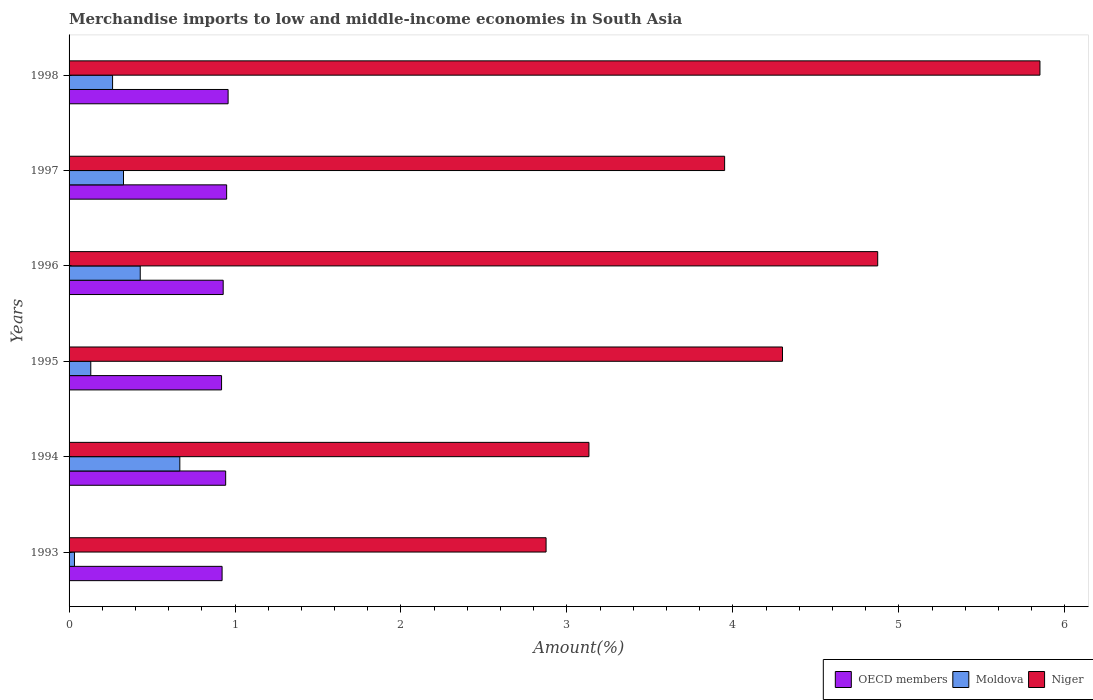How many different coloured bars are there?
Make the answer very short. 3. How many groups of bars are there?
Offer a very short reply. 6. Are the number of bars per tick equal to the number of legend labels?
Provide a succinct answer. Yes. How many bars are there on the 6th tick from the top?
Offer a terse response. 3. What is the label of the 1st group of bars from the top?
Make the answer very short. 1998. In how many cases, is the number of bars for a given year not equal to the number of legend labels?
Your answer should be very brief. 0. What is the percentage of amount earned from merchandise imports in OECD members in 1997?
Give a very brief answer. 0.95. Across all years, what is the maximum percentage of amount earned from merchandise imports in Moldova?
Provide a short and direct response. 0.67. Across all years, what is the minimum percentage of amount earned from merchandise imports in Niger?
Your answer should be very brief. 2.87. In which year was the percentage of amount earned from merchandise imports in Moldova minimum?
Provide a short and direct response. 1993. What is the total percentage of amount earned from merchandise imports in Niger in the graph?
Keep it short and to the point. 24.98. What is the difference between the percentage of amount earned from merchandise imports in Niger in 1994 and that in 1997?
Offer a terse response. -0.82. What is the difference between the percentage of amount earned from merchandise imports in Moldova in 1993 and the percentage of amount earned from merchandise imports in Niger in 1995?
Make the answer very short. -4.27. What is the average percentage of amount earned from merchandise imports in Niger per year?
Provide a short and direct response. 4.16. In the year 1996, what is the difference between the percentage of amount earned from merchandise imports in OECD members and percentage of amount earned from merchandise imports in Moldova?
Offer a terse response. 0.5. In how many years, is the percentage of amount earned from merchandise imports in Niger greater than 3 %?
Provide a short and direct response. 5. What is the ratio of the percentage of amount earned from merchandise imports in OECD members in 1993 to that in 1994?
Keep it short and to the point. 0.98. Is the percentage of amount earned from merchandise imports in Moldova in 1994 less than that in 1997?
Ensure brevity in your answer.  No. What is the difference between the highest and the second highest percentage of amount earned from merchandise imports in OECD members?
Your answer should be compact. 0.01. What is the difference between the highest and the lowest percentage of amount earned from merchandise imports in Niger?
Provide a succinct answer. 2.98. Is the sum of the percentage of amount earned from merchandise imports in Niger in 1994 and 1997 greater than the maximum percentage of amount earned from merchandise imports in OECD members across all years?
Provide a succinct answer. Yes. What does the 1st bar from the top in 1993 represents?
Provide a succinct answer. Niger. What does the 2nd bar from the bottom in 1995 represents?
Your response must be concise. Moldova. Is it the case that in every year, the sum of the percentage of amount earned from merchandise imports in Niger and percentage of amount earned from merchandise imports in Moldova is greater than the percentage of amount earned from merchandise imports in OECD members?
Provide a succinct answer. Yes. Are all the bars in the graph horizontal?
Provide a succinct answer. Yes. How many years are there in the graph?
Provide a short and direct response. 6. Are the values on the major ticks of X-axis written in scientific E-notation?
Keep it short and to the point. No. Does the graph contain any zero values?
Ensure brevity in your answer.  No. Where does the legend appear in the graph?
Make the answer very short. Bottom right. How many legend labels are there?
Your answer should be compact. 3. What is the title of the graph?
Your answer should be very brief. Merchandise imports to low and middle-income economies in South Asia. Does "Peru" appear as one of the legend labels in the graph?
Your response must be concise. No. What is the label or title of the X-axis?
Your answer should be very brief. Amount(%). What is the label or title of the Y-axis?
Provide a succinct answer. Years. What is the Amount(%) of OECD members in 1993?
Your answer should be very brief. 0.92. What is the Amount(%) in Moldova in 1993?
Ensure brevity in your answer.  0.03. What is the Amount(%) of Niger in 1993?
Provide a short and direct response. 2.87. What is the Amount(%) in OECD members in 1994?
Give a very brief answer. 0.94. What is the Amount(%) of Moldova in 1994?
Keep it short and to the point. 0.67. What is the Amount(%) of Niger in 1994?
Offer a terse response. 3.13. What is the Amount(%) of OECD members in 1995?
Keep it short and to the point. 0.92. What is the Amount(%) of Moldova in 1995?
Give a very brief answer. 0.13. What is the Amount(%) in Niger in 1995?
Ensure brevity in your answer.  4.3. What is the Amount(%) in OECD members in 1996?
Offer a terse response. 0.93. What is the Amount(%) of Moldova in 1996?
Provide a short and direct response. 0.43. What is the Amount(%) in Niger in 1996?
Ensure brevity in your answer.  4.87. What is the Amount(%) in OECD members in 1997?
Your answer should be very brief. 0.95. What is the Amount(%) of Moldova in 1997?
Provide a succinct answer. 0.33. What is the Amount(%) of Niger in 1997?
Keep it short and to the point. 3.95. What is the Amount(%) in OECD members in 1998?
Make the answer very short. 0.96. What is the Amount(%) of Moldova in 1998?
Provide a succinct answer. 0.26. What is the Amount(%) of Niger in 1998?
Offer a very short reply. 5.85. Across all years, what is the maximum Amount(%) of OECD members?
Offer a terse response. 0.96. Across all years, what is the maximum Amount(%) in Moldova?
Provide a short and direct response. 0.67. Across all years, what is the maximum Amount(%) of Niger?
Keep it short and to the point. 5.85. Across all years, what is the minimum Amount(%) of OECD members?
Your answer should be compact. 0.92. Across all years, what is the minimum Amount(%) of Moldova?
Provide a succinct answer. 0.03. Across all years, what is the minimum Amount(%) in Niger?
Your response must be concise. 2.87. What is the total Amount(%) of OECD members in the graph?
Your response must be concise. 5.62. What is the total Amount(%) of Moldova in the graph?
Offer a terse response. 1.85. What is the total Amount(%) in Niger in the graph?
Give a very brief answer. 24.98. What is the difference between the Amount(%) of OECD members in 1993 and that in 1994?
Your answer should be very brief. -0.02. What is the difference between the Amount(%) of Moldova in 1993 and that in 1994?
Keep it short and to the point. -0.63. What is the difference between the Amount(%) of Niger in 1993 and that in 1994?
Provide a short and direct response. -0.26. What is the difference between the Amount(%) of OECD members in 1993 and that in 1995?
Provide a short and direct response. 0. What is the difference between the Amount(%) of Moldova in 1993 and that in 1995?
Your response must be concise. -0.1. What is the difference between the Amount(%) in Niger in 1993 and that in 1995?
Offer a very short reply. -1.42. What is the difference between the Amount(%) in OECD members in 1993 and that in 1996?
Provide a short and direct response. -0.01. What is the difference between the Amount(%) in Moldova in 1993 and that in 1996?
Offer a very short reply. -0.4. What is the difference between the Amount(%) in Niger in 1993 and that in 1996?
Make the answer very short. -2. What is the difference between the Amount(%) in OECD members in 1993 and that in 1997?
Your answer should be very brief. -0.03. What is the difference between the Amount(%) in Moldova in 1993 and that in 1997?
Ensure brevity in your answer.  -0.3. What is the difference between the Amount(%) in Niger in 1993 and that in 1997?
Your answer should be compact. -1.08. What is the difference between the Amount(%) in OECD members in 1993 and that in 1998?
Your response must be concise. -0.04. What is the difference between the Amount(%) of Moldova in 1993 and that in 1998?
Provide a succinct answer. -0.23. What is the difference between the Amount(%) of Niger in 1993 and that in 1998?
Keep it short and to the point. -2.98. What is the difference between the Amount(%) in OECD members in 1994 and that in 1995?
Offer a terse response. 0.02. What is the difference between the Amount(%) of Moldova in 1994 and that in 1995?
Provide a succinct answer. 0.54. What is the difference between the Amount(%) of Niger in 1994 and that in 1995?
Your answer should be very brief. -1.17. What is the difference between the Amount(%) in OECD members in 1994 and that in 1996?
Provide a succinct answer. 0.01. What is the difference between the Amount(%) in Moldova in 1994 and that in 1996?
Offer a terse response. 0.24. What is the difference between the Amount(%) in Niger in 1994 and that in 1996?
Offer a very short reply. -1.74. What is the difference between the Amount(%) of OECD members in 1994 and that in 1997?
Provide a short and direct response. -0.01. What is the difference between the Amount(%) in Moldova in 1994 and that in 1997?
Keep it short and to the point. 0.34. What is the difference between the Amount(%) in Niger in 1994 and that in 1997?
Make the answer very short. -0.82. What is the difference between the Amount(%) in OECD members in 1994 and that in 1998?
Provide a succinct answer. -0.01. What is the difference between the Amount(%) of Moldova in 1994 and that in 1998?
Your answer should be compact. 0.41. What is the difference between the Amount(%) in Niger in 1994 and that in 1998?
Offer a very short reply. -2.72. What is the difference between the Amount(%) of OECD members in 1995 and that in 1996?
Give a very brief answer. -0.01. What is the difference between the Amount(%) in Moldova in 1995 and that in 1996?
Your answer should be very brief. -0.3. What is the difference between the Amount(%) in Niger in 1995 and that in 1996?
Ensure brevity in your answer.  -0.57. What is the difference between the Amount(%) of OECD members in 1995 and that in 1997?
Provide a short and direct response. -0.03. What is the difference between the Amount(%) in Moldova in 1995 and that in 1997?
Offer a very short reply. -0.2. What is the difference between the Amount(%) of Niger in 1995 and that in 1997?
Provide a short and direct response. 0.35. What is the difference between the Amount(%) in OECD members in 1995 and that in 1998?
Keep it short and to the point. -0.04. What is the difference between the Amount(%) in Moldova in 1995 and that in 1998?
Give a very brief answer. -0.13. What is the difference between the Amount(%) of Niger in 1995 and that in 1998?
Offer a very short reply. -1.55. What is the difference between the Amount(%) of OECD members in 1996 and that in 1997?
Provide a succinct answer. -0.02. What is the difference between the Amount(%) of Moldova in 1996 and that in 1997?
Make the answer very short. 0.1. What is the difference between the Amount(%) in Niger in 1996 and that in 1997?
Your answer should be compact. 0.92. What is the difference between the Amount(%) of OECD members in 1996 and that in 1998?
Provide a succinct answer. -0.03. What is the difference between the Amount(%) in Moldova in 1996 and that in 1998?
Your response must be concise. 0.17. What is the difference between the Amount(%) of Niger in 1996 and that in 1998?
Provide a succinct answer. -0.98. What is the difference between the Amount(%) of OECD members in 1997 and that in 1998?
Your response must be concise. -0.01. What is the difference between the Amount(%) in Moldova in 1997 and that in 1998?
Offer a terse response. 0.07. What is the difference between the Amount(%) in Niger in 1997 and that in 1998?
Provide a short and direct response. -1.9. What is the difference between the Amount(%) in OECD members in 1993 and the Amount(%) in Moldova in 1994?
Offer a terse response. 0.25. What is the difference between the Amount(%) in OECD members in 1993 and the Amount(%) in Niger in 1994?
Offer a very short reply. -2.21. What is the difference between the Amount(%) in Moldova in 1993 and the Amount(%) in Niger in 1994?
Provide a short and direct response. -3.1. What is the difference between the Amount(%) of OECD members in 1993 and the Amount(%) of Moldova in 1995?
Offer a terse response. 0.79. What is the difference between the Amount(%) in OECD members in 1993 and the Amount(%) in Niger in 1995?
Make the answer very short. -3.38. What is the difference between the Amount(%) in Moldova in 1993 and the Amount(%) in Niger in 1995?
Make the answer very short. -4.27. What is the difference between the Amount(%) in OECD members in 1993 and the Amount(%) in Moldova in 1996?
Provide a succinct answer. 0.49. What is the difference between the Amount(%) of OECD members in 1993 and the Amount(%) of Niger in 1996?
Keep it short and to the point. -3.95. What is the difference between the Amount(%) in Moldova in 1993 and the Amount(%) in Niger in 1996?
Make the answer very short. -4.84. What is the difference between the Amount(%) in OECD members in 1993 and the Amount(%) in Moldova in 1997?
Your answer should be compact. 0.59. What is the difference between the Amount(%) in OECD members in 1993 and the Amount(%) in Niger in 1997?
Give a very brief answer. -3.03. What is the difference between the Amount(%) of Moldova in 1993 and the Amount(%) of Niger in 1997?
Offer a very short reply. -3.92. What is the difference between the Amount(%) of OECD members in 1993 and the Amount(%) of Moldova in 1998?
Offer a terse response. 0.66. What is the difference between the Amount(%) in OECD members in 1993 and the Amount(%) in Niger in 1998?
Your response must be concise. -4.93. What is the difference between the Amount(%) of Moldova in 1993 and the Amount(%) of Niger in 1998?
Provide a succinct answer. -5.82. What is the difference between the Amount(%) in OECD members in 1994 and the Amount(%) in Moldova in 1995?
Keep it short and to the point. 0.81. What is the difference between the Amount(%) of OECD members in 1994 and the Amount(%) of Niger in 1995?
Your response must be concise. -3.36. What is the difference between the Amount(%) in Moldova in 1994 and the Amount(%) in Niger in 1995?
Provide a succinct answer. -3.63. What is the difference between the Amount(%) in OECD members in 1994 and the Amount(%) in Moldova in 1996?
Provide a short and direct response. 0.51. What is the difference between the Amount(%) in OECD members in 1994 and the Amount(%) in Niger in 1996?
Your response must be concise. -3.93. What is the difference between the Amount(%) in Moldova in 1994 and the Amount(%) in Niger in 1996?
Your response must be concise. -4.21. What is the difference between the Amount(%) in OECD members in 1994 and the Amount(%) in Moldova in 1997?
Your response must be concise. 0.62. What is the difference between the Amount(%) of OECD members in 1994 and the Amount(%) of Niger in 1997?
Make the answer very short. -3.01. What is the difference between the Amount(%) of Moldova in 1994 and the Amount(%) of Niger in 1997?
Provide a succinct answer. -3.28. What is the difference between the Amount(%) in OECD members in 1994 and the Amount(%) in Moldova in 1998?
Provide a short and direct response. 0.68. What is the difference between the Amount(%) of OECD members in 1994 and the Amount(%) of Niger in 1998?
Provide a succinct answer. -4.91. What is the difference between the Amount(%) in Moldova in 1994 and the Amount(%) in Niger in 1998?
Give a very brief answer. -5.18. What is the difference between the Amount(%) of OECD members in 1995 and the Amount(%) of Moldova in 1996?
Your answer should be very brief. 0.49. What is the difference between the Amount(%) in OECD members in 1995 and the Amount(%) in Niger in 1996?
Provide a short and direct response. -3.95. What is the difference between the Amount(%) of Moldova in 1995 and the Amount(%) of Niger in 1996?
Make the answer very short. -4.74. What is the difference between the Amount(%) in OECD members in 1995 and the Amount(%) in Moldova in 1997?
Offer a very short reply. 0.59. What is the difference between the Amount(%) in OECD members in 1995 and the Amount(%) in Niger in 1997?
Your response must be concise. -3.03. What is the difference between the Amount(%) in Moldova in 1995 and the Amount(%) in Niger in 1997?
Provide a short and direct response. -3.82. What is the difference between the Amount(%) of OECD members in 1995 and the Amount(%) of Moldova in 1998?
Offer a very short reply. 0.66. What is the difference between the Amount(%) of OECD members in 1995 and the Amount(%) of Niger in 1998?
Keep it short and to the point. -4.93. What is the difference between the Amount(%) in Moldova in 1995 and the Amount(%) in Niger in 1998?
Keep it short and to the point. -5.72. What is the difference between the Amount(%) of OECD members in 1996 and the Amount(%) of Moldova in 1997?
Ensure brevity in your answer.  0.6. What is the difference between the Amount(%) of OECD members in 1996 and the Amount(%) of Niger in 1997?
Ensure brevity in your answer.  -3.02. What is the difference between the Amount(%) of Moldova in 1996 and the Amount(%) of Niger in 1997?
Keep it short and to the point. -3.52. What is the difference between the Amount(%) of OECD members in 1996 and the Amount(%) of Moldova in 1998?
Your answer should be compact. 0.67. What is the difference between the Amount(%) of OECD members in 1996 and the Amount(%) of Niger in 1998?
Keep it short and to the point. -4.92. What is the difference between the Amount(%) of Moldova in 1996 and the Amount(%) of Niger in 1998?
Ensure brevity in your answer.  -5.42. What is the difference between the Amount(%) of OECD members in 1997 and the Amount(%) of Moldova in 1998?
Offer a terse response. 0.69. What is the difference between the Amount(%) of OECD members in 1997 and the Amount(%) of Niger in 1998?
Make the answer very short. -4.9. What is the difference between the Amount(%) in Moldova in 1997 and the Amount(%) in Niger in 1998?
Offer a terse response. -5.52. What is the average Amount(%) of OECD members per year?
Make the answer very short. 0.94. What is the average Amount(%) of Moldova per year?
Your answer should be compact. 0.31. What is the average Amount(%) of Niger per year?
Offer a very short reply. 4.16. In the year 1993, what is the difference between the Amount(%) of OECD members and Amount(%) of Moldova?
Your answer should be compact. 0.89. In the year 1993, what is the difference between the Amount(%) of OECD members and Amount(%) of Niger?
Offer a terse response. -1.95. In the year 1993, what is the difference between the Amount(%) in Moldova and Amount(%) in Niger?
Keep it short and to the point. -2.84. In the year 1994, what is the difference between the Amount(%) in OECD members and Amount(%) in Moldova?
Ensure brevity in your answer.  0.28. In the year 1994, what is the difference between the Amount(%) of OECD members and Amount(%) of Niger?
Give a very brief answer. -2.19. In the year 1994, what is the difference between the Amount(%) of Moldova and Amount(%) of Niger?
Ensure brevity in your answer.  -2.47. In the year 1995, what is the difference between the Amount(%) of OECD members and Amount(%) of Moldova?
Your answer should be very brief. 0.79. In the year 1995, what is the difference between the Amount(%) in OECD members and Amount(%) in Niger?
Offer a terse response. -3.38. In the year 1995, what is the difference between the Amount(%) in Moldova and Amount(%) in Niger?
Provide a succinct answer. -4.17. In the year 1996, what is the difference between the Amount(%) in OECD members and Amount(%) in Moldova?
Offer a very short reply. 0.5. In the year 1996, what is the difference between the Amount(%) in OECD members and Amount(%) in Niger?
Give a very brief answer. -3.94. In the year 1996, what is the difference between the Amount(%) of Moldova and Amount(%) of Niger?
Give a very brief answer. -4.44. In the year 1997, what is the difference between the Amount(%) in OECD members and Amount(%) in Moldova?
Offer a very short reply. 0.62. In the year 1997, what is the difference between the Amount(%) in OECD members and Amount(%) in Niger?
Provide a succinct answer. -3. In the year 1997, what is the difference between the Amount(%) of Moldova and Amount(%) of Niger?
Give a very brief answer. -3.62. In the year 1998, what is the difference between the Amount(%) of OECD members and Amount(%) of Moldova?
Ensure brevity in your answer.  0.7. In the year 1998, what is the difference between the Amount(%) of OECD members and Amount(%) of Niger?
Ensure brevity in your answer.  -4.89. In the year 1998, what is the difference between the Amount(%) in Moldova and Amount(%) in Niger?
Ensure brevity in your answer.  -5.59. What is the ratio of the Amount(%) in OECD members in 1993 to that in 1994?
Make the answer very short. 0.98. What is the ratio of the Amount(%) in Moldova in 1993 to that in 1994?
Keep it short and to the point. 0.05. What is the ratio of the Amount(%) in Niger in 1993 to that in 1994?
Offer a very short reply. 0.92. What is the ratio of the Amount(%) of OECD members in 1993 to that in 1995?
Your answer should be very brief. 1. What is the ratio of the Amount(%) of Moldova in 1993 to that in 1995?
Offer a very short reply. 0.25. What is the ratio of the Amount(%) in Niger in 1993 to that in 1995?
Provide a short and direct response. 0.67. What is the ratio of the Amount(%) of OECD members in 1993 to that in 1996?
Offer a terse response. 0.99. What is the ratio of the Amount(%) of Moldova in 1993 to that in 1996?
Provide a succinct answer. 0.08. What is the ratio of the Amount(%) in Niger in 1993 to that in 1996?
Offer a very short reply. 0.59. What is the ratio of the Amount(%) of OECD members in 1993 to that in 1997?
Provide a succinct answer. 0.97. What is the ratio of the Amount(%) of Moldova in 1993 to that in 1997?
Offer a very short reply. 0.1. What is the ratio of the Amount(%) in Niger in 1993 to that in 1997?
Offer a very short reply. 0.73. What is the ratio of the Amount(%) in OECD members in 1993 to that in 1998?
Provide a short and direct response. 0.96. What is the ratio of the Amount(%) in Moldova in 1993 to that in 1998?
Your answer should be very brief. 0.12. What is the ratio of the Amount(%) of Niger in 1993 to that in 1998?
Offer a very short reply. 0.49. What is the ratio of the Amount(%) in OECD members in 1994 to that in 1995?
Your answer should be very brief. 1.03. What is the ratio of the Amount(%) in Niger in 1994 to that in 1995?
Ensure brevity in your answer.  0.73. What is the ratio of the Amount(%) of OECD members in 1994 to that in 1996?
Offer a very short reply. 1.02. What is the ratio of the Amount(%) of Moldova in 1994 to that in 1996?
Give a very brief answer. 1.56. What is the ratio of the Amount(%) in Niger in 1994 to that in 1996?
Give a very brief answer. 0.64. What is the ratio of the Amount(%) of OECD members in 1994 to that in 1997?
Ensure brevity in your answer.  0.99. What is the ratio of the Amount(%) in Moldova in 1994 to that in 1997?
Offer a very short reply. 2.03. What is the ratio of the Amount(%) in Niger in 1994 to that in 1997?
Your answer should be compact. 0.79. What is the ratio of the Amount(%) of OECD members in 1994 to that in 1998?
Offer a terse response. 0.98. What is the ratio of the Amount(%) in Moldova in 1994 to that in 1998?
Offer a terse response. 2.55. What is the ratio of the Amount(%) in Niger in 1994 to that in 1998?
Your answer should be very brief. 0.54. What is the ratio of the Amount(%) in Moldova in 1995 to that in 1996?
Your response must be concise. 0.31. What is the ratio of the Amount(%) of Niger in 1995 to that in 1996?
Your answer should be very brief. 0.88. What is the ratio of the Amount(%) of OECD members in 1995 to that in 1997?
Provide a succinct answer. 0.97. What is the ratio of the Amount(%) of Moldova in 1995 to that in 1997?
Provide a short and direct response. 0.4. What is the ratio of the Amount(%) in Niger in 1995 to that in 1997?
Provide a short and direct response. 1.09. What is the ratio of the Amount(%) of OECD members in 1995 to that in 1998?
Ensure brevity in your answer.  0.96. What is the ratio of the Amount(%) of Moldova in 1995 to that in 1998?
Keep it short and to the point. 0.5. What is the ratio of the Amount(%) in Niger in 1995 to that in 1998?
Your answer should be compact. 0.73. What is the ratio of the Amount(%) in OECD members in 1996 to that in 1997?
Provide a short and direct response. 0.98. What is the ratio of the Amount(%) in Moldova in 1996 to that in 1997?
Keep it short and to the point. 1.31. What is the ratio of the Amount(%) of Niger in 1996 to that in 1997?
Ensure brevity in your answer.  1.23. What is the ratio of the Amount(%) in OECD members in 1996 to that in 1998?
Provide a succinct answer. 0.97. What is the ratio of the Amount(%) in Moldova in 1996 to that in 1998?
Your answer should be compact. 1.64. What is the ratio of the Amount(%) of Niger in 1996 to that in 1998?
Provide a succinct answer. 0.83. What is the ratio of the Amount(%) in Moldova in 1997 to that in 1998?
Offer a very short reply. 1.25. What is the ratio of the Amount(%) of Niger in 1997 to that in 1998?
Offer a very short reply. 0.68. What is the difference between the highest and the second highest Amount(%) in OECD members?
Make the answer very short. 0.01. What is the difference between the highest and the second highest Amount(%) in Moldova?
Your answer should be compact. 0.24. What is the difference between the highest and the second highest Amount(%) of Niger?
Your answer should be very brief. 0.98. What is the difference between the highest and the lowest Amount(%) in OECD members?
Provide a short and direct response. 0.04. What is the difference between the highest and the lowest Amount(%) in Moldova?
Offer a very short reply. 0.63. What is the difference between the highest and the lowest Amount(%) in Niger?
Offer a very short reply. 2.98. 